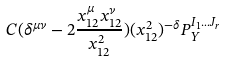<formula> <loc_0><loc_0><loc_500><loc_500>C ( \delta ^ { \mu \nu } - 2 \frac { x _ { 1 2 } ^ { \mu } x _ { 1 2 } ^ { \nu } } { x _ { 1 2 } ^ { 2 } } ) ( x _ { 1 2 } ^ { 2 } ) ^ { - \delta } P _ { Y } ^ { I _ { 1 } \dots J _ { r } }</formula> 